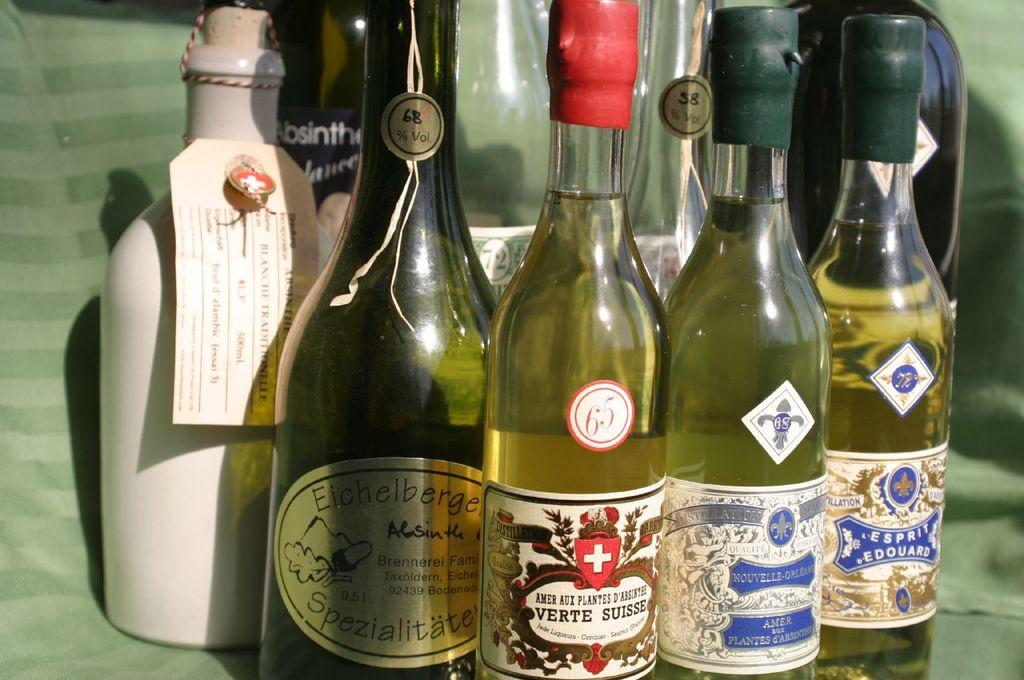What is the number on the top of the bottle that is in the middle?
Your answer should be very brief. 58. What is the number before the % symbol?
Provide a short and direct response. 68. 